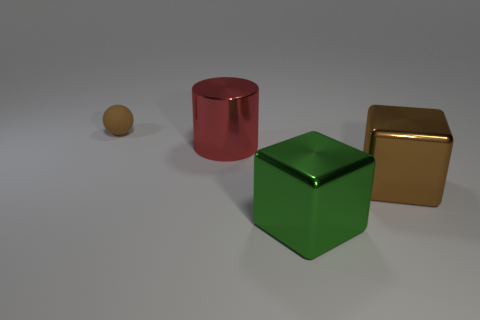How many red objects are either matte spheres or big objects?
Your answer should be compact. 1. There is a red cylinder that is the same size as the green metal thing; what is it made of?
Give a very brief answer. Metal. There is a thing that is in front of the small rubber sphere and to the left of the big green metallic cube; what is its shape?
Give a very brief answer. Cylinder. There is another cube that is the same size as the brown metallic cube; what color is it?
Your answer should be very brief. Green. There is a brown thing left of the brown metal block; is its size the same as the brown object in front of the big red thing?
Offer a terse response. No. There is a shiny object that is on the right side of the large block that is in front of the brown object that is in front of the brown sphere; how big is it?
Give a very brief answer. Large. The thing behind the big metal thing on the left side of the green metal object is what shape?
Your answer should be very brief. Sphere. Is the color of the metallic cube on the right side of the large green cube the same as the small rubber ball?
Your response must be concise. Yes. There is a thing that is to the left of the green metallic object and right of the matte object; what color is it?
Your answer should be compact. Red. Is there a big yellow block that has the same material as the large green thing?
Offer a very short reply. No. 